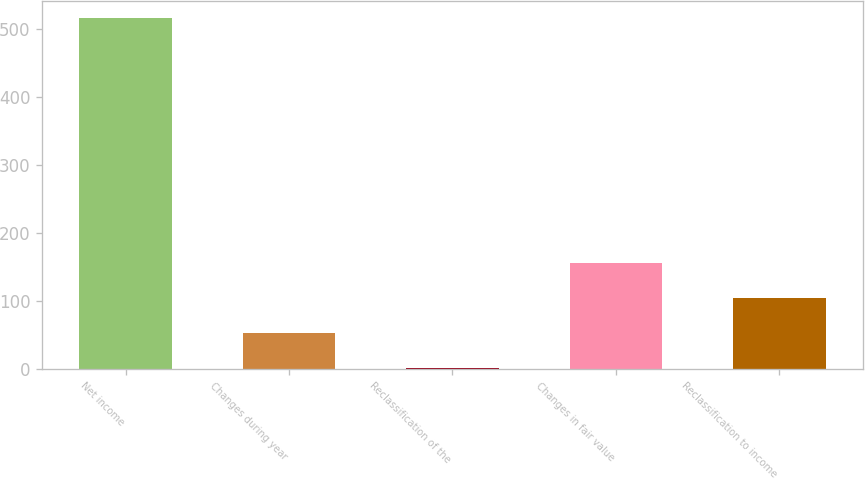Convert chart. <chart><loc_0><loc_0><loc_500><loc_500><bar_chart><fcel>Net income<fcel>Changes during year<fcel>Reclassification of the<fcel>Changes in fair value<fcel>Reclassification to income<nl><fcel>516<fcel>52.5<fcel>1<fcel>155.5<fcel>104<nl></chart> 